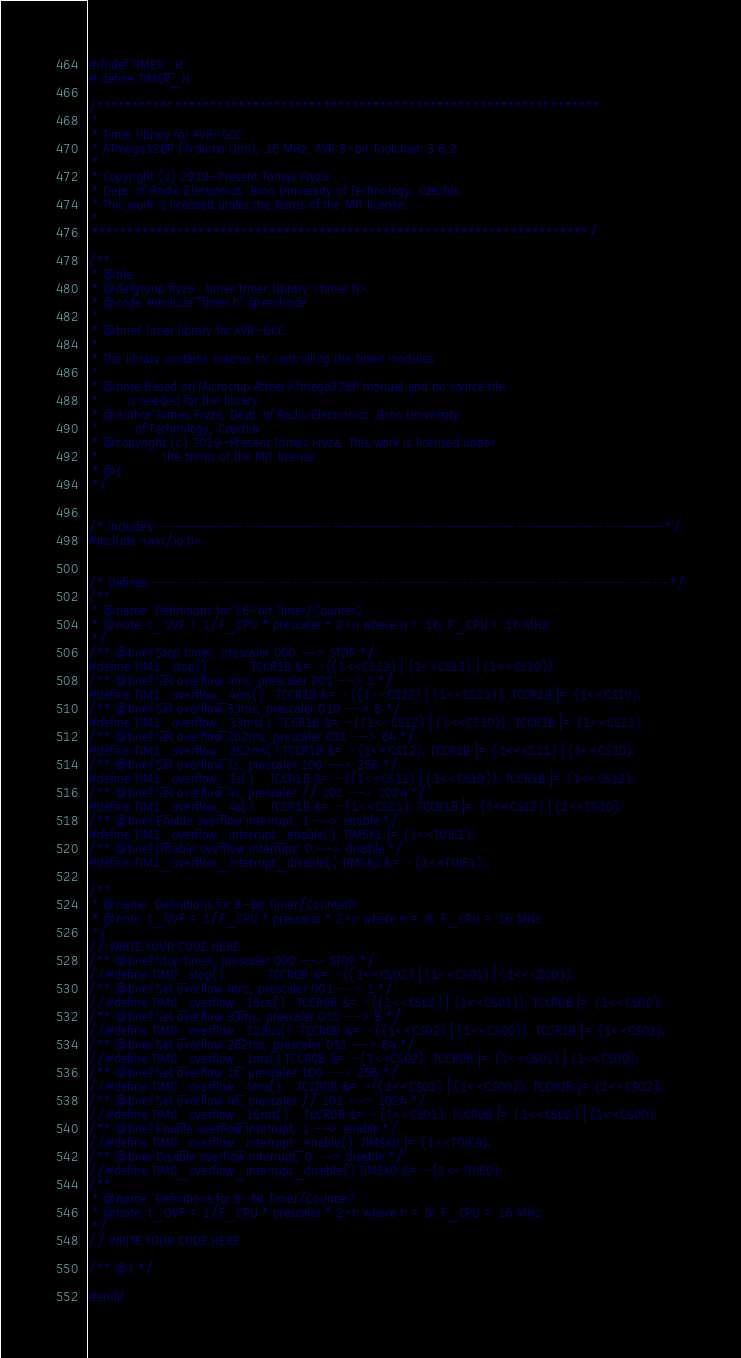<code> <loc_0><loc_0><loc_500><loc_500><_C_>#ifndef TIMER_H
# define TIMER_H

/***********************************************************************
 * 
 * Timer library for AVR-GCC.
 * ATmega328P (Arduino Uno), 16 MHz, AVR 8-bit Toolchain 3.6.2
 *
 * Copyright (c) 2019-Present Tomas Fryza
 * Dept. of Radio Electronics, Brno University of Technology, Czechia
 * This work is licensed under the terms of the MIT license.
 *
 **********************************************************************/

/**
 * @file 
 * @defgroup fryza_timer Timer Library <timer.h>
 * @code #include "timer.h" @endcode
 *
 * @brief Timer library for AVR-GCC.
 *
 * The library contains macros for controlling the timer modules.
 *
 * @note Based on Microchip Atmel ATmega328P manual and no source file
 *       is needed for the library.
 * @author Tomas Fryza, Dept. of Radio Electronics, Brno University 
 *         of Technology, Czechia
 * @copyright (c) 2019-Present Tomas Fryza, This work is licensed under 
 *                the terms of the MIT license
 * @{
 */


/* Includes ----------------------------------------------------------*/
#include <avr/io.h>


/* Defines -----------------------------------------------------------*/
/**
 * @name  Definitions for 16-bit Timer/Counter1
 * @note  t_OVF = 1/F_CPU * prescaler * 2^n where n = 16, F_CPU = 16 MHz
 */
/** @brief Stop timer, prescaler 000 --> STOP */
#define TIM1_stop()           TCCR1B &= ~((1<<CS12) | (1<<CS11) | (1<<CS10));
/** @brief Set overflow 4ms, prescaler 001 --> 1 */
#define TIM1_overflow_4ms()   TCCR1B &= ~((1<<CS12) | (1<<CS11)); TCCR1B |= (1<<CS10);
/** @brief Set overflow 33ms, prescaler 010 --> 8 */
#define TIM1_overflow_33ms()  TCCR1B &= ~((1<<CS12) | (1<<CS10)); TCCR1B |= (1<<CS11);
/** @brief Set overflow 262ms, prescaler 011 --> 64 */
#define TIM1_overflow_262ms() TCCR1B &= ~(1<<CS12); TCCR1B |= (1<<CS11) | (1<<CS10);
/** @brief Set overflow 1s, prescaler 100 --> 256 */
#define TIM1_overflow_1s()    TCCR1B &= ~((1<<CS11) | (1<<CS10)); TCCR1B |= (1<<CS12);
/** @brief Set overflow 4s, prescaler // 101 --> 1024 */
#define TIM1_overflow_4s()    TCCR1B &= ~(1<<CS11); TCCR1B |= (1<<CS12) | (1<<CS10);
/** @brief Enable overflow interrupt, 1 --> enable */
#define TIM1_overflow_interrupt_enable()  TIMSK1 |= (1<<TOIE1);
/** @brief Disable overflow interrupt, 0 --> disable */
#define TIM1_overflow_interrupt_disable() TIMSK1 &= ~(1<<TOIE1);

/**
 * @name  Definitions for 8-bit Timer/Counter0
 * @note  t_OVF = 1/F_CPU * prescaler * 2^n where n = 8, F_CPU = 16 MHz
 */
// WRITE YOUR CODE HERE
/** @brief Stop timer, prescaler 000 --> STOP */
//#define TIM0_stop()           TCCR0B &= ~((1<<CS02) | (1<<CS01) | (1<<CS00));
/** @brief Set overflow 4ms, prescaler 001 --> 1 */
//#define TIM0_overflow_16us()   TCCR0B &= ~((1<<CS02) | (1<<CS01)); TCCR0B |= (1<<CS00);
/** @brief Set overflow 33ms, prescaler 010 --> 8 */
//#define TIM0_overflow_128us()  TCCR0B &= ~((1<<CS02) | (1<<CS00)); TCCR1B |= (1<<CS01);
/** @brief Set overflow 262ms, prescaler 011 --> 64 */
//#define TIM0_overflow_1ms() TCCR0B &= ~(1<<CS02); TCCR0B |= (1<<CS01) | (1<<CS00);
/** @brief Set overflow 1s, prescaler 100 --> 256 */
//#define TIM0_overflow_4ms()    TCCR0B &= ~((1<<CS01) | (1<<CS00)); TCCR0B |= (1<<CS02);
/** @brief Set overflow 4s, prescaler // 101 --> 1024 */
//#define TIM0_overflow_16ms()    TCCR0B &= ~(1<<CS01); TCCR0B |= (1<<CS02) | (1<<CS00);
/** @brief Enable overflow interrupt, 1 --> enable */
//#define TIM0_overflow_interrupt_enable()  TIMSK0 |= (1<<TOIE0);
/** @brief Disable overflow interrupt, 0 --> disable */
//#define TIM0_overflow_interrupt_disable() TIMSK0 &= ~(1<<TOIE0);
/**
 * @name  Definitions for 8-bit Timer/Counter2
 * @note  t_OVF = 1/F_CPU * prescaler * 2^n where n = 8, F_CPU = 16 MHz
 */
// WRITE YOUR CODE HERE

/** @} */

#endif</code> 